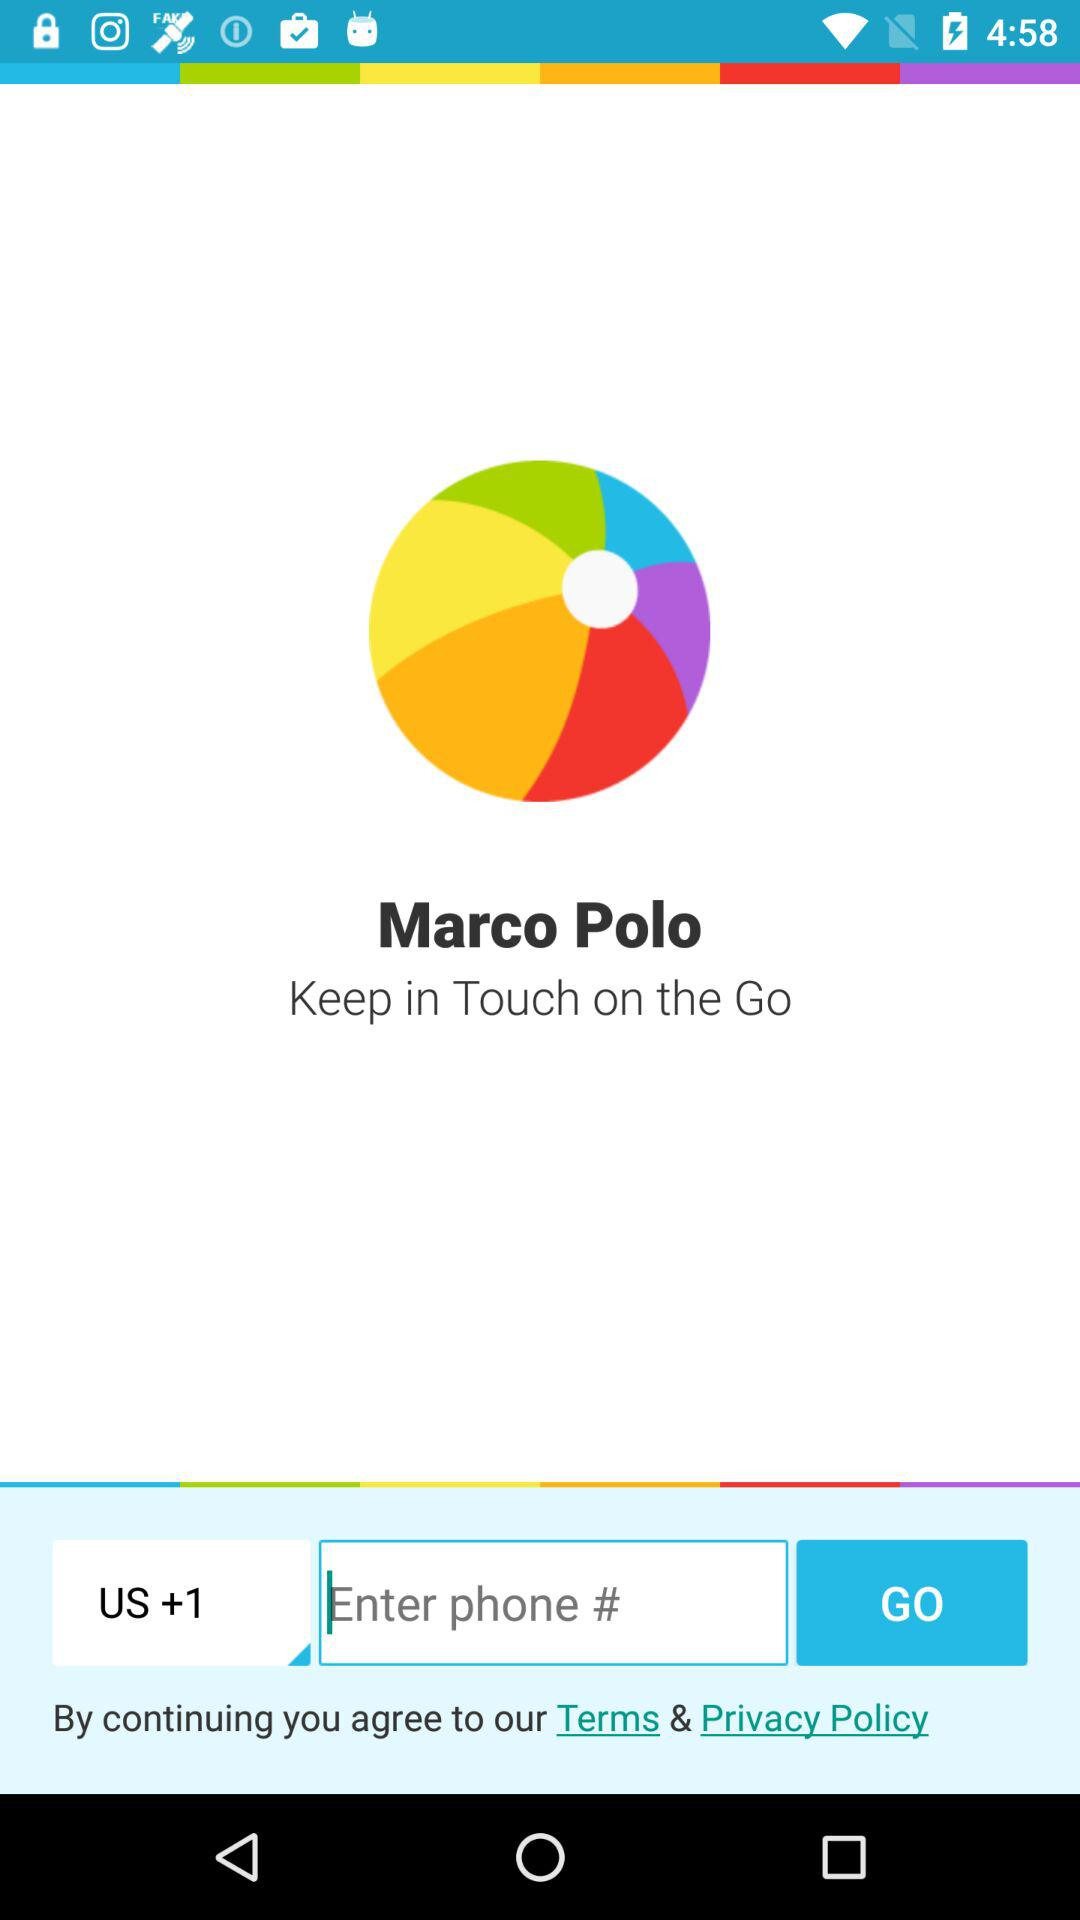Which country code is selected? The selected country code is +1. 